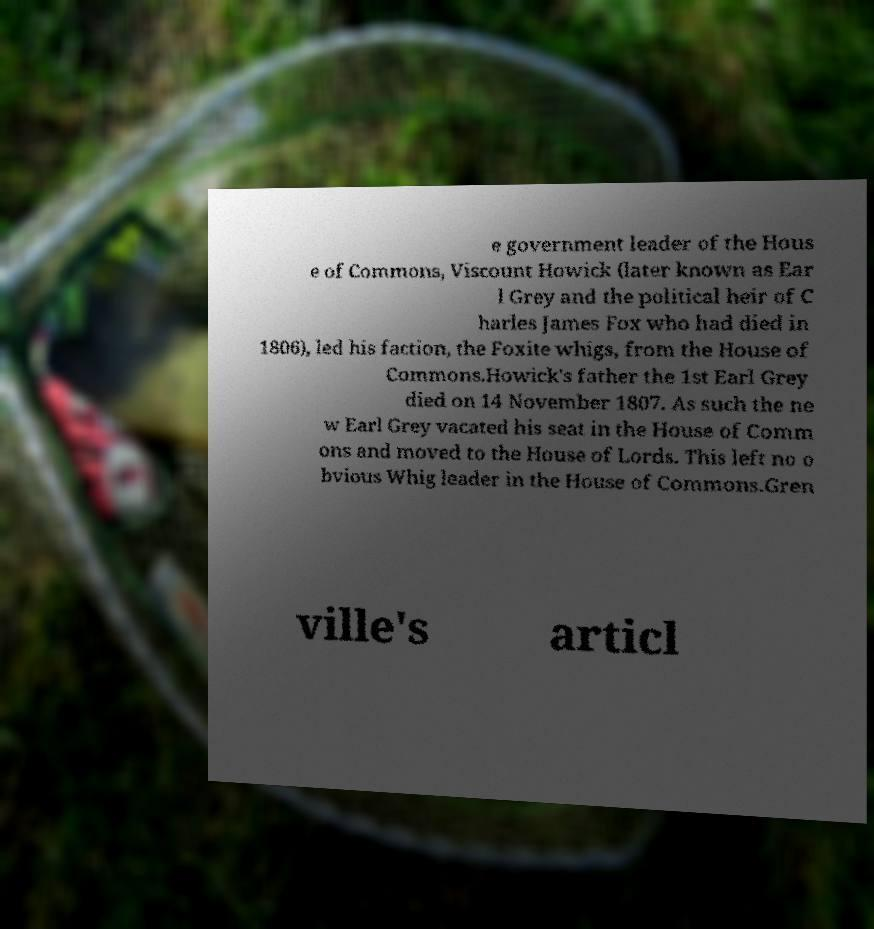Can you read and provide the text displayed in the image?This photo seems to have some interesting text. Can you extract and type it out for me? e government leader of the Hous e of Commons, Viscount Howick (later known as Ear l Grey and the political heir of C harles James Fox who had died in 1806), led his faction, the Foxite whigs, from the House of Commons.Howick's father the 1st Earl Grey died on 14 November 1807. As such the ne w Earl Grey vacated his seat in the House of Comm ons and moved to the House of Lords. This left no o bvious Whig leader in the House of Commons.Gren ville's articl 